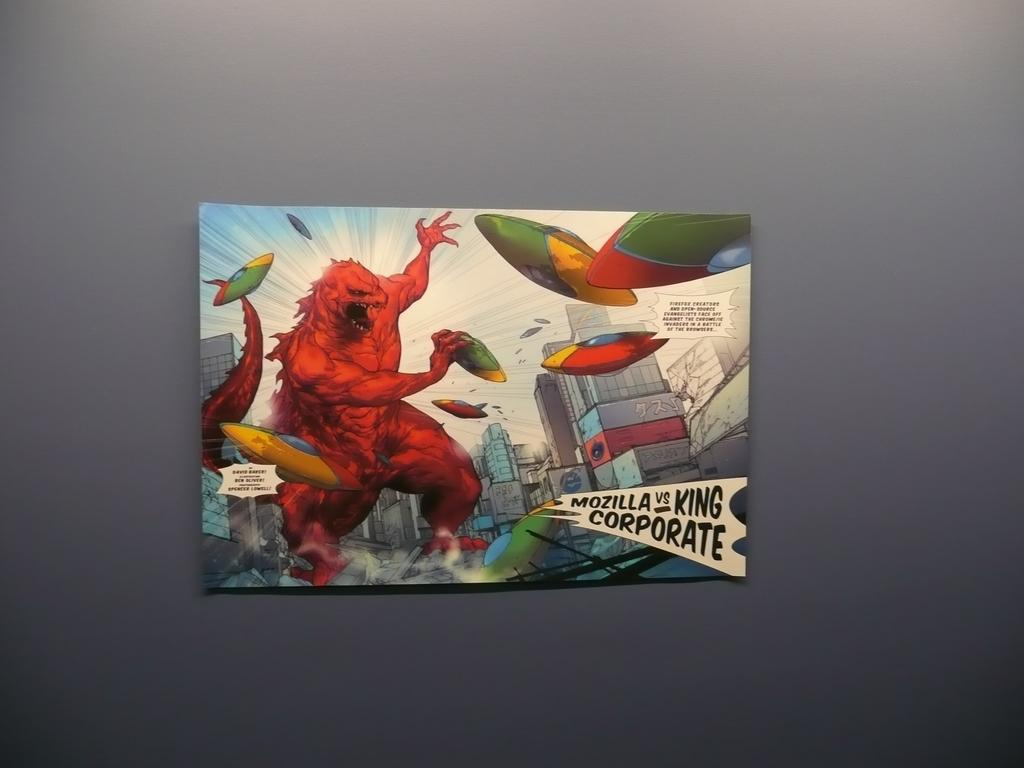Provide a one-sentence caption for the provided image. A painting of depicting Mozilla as a comic book monster. 